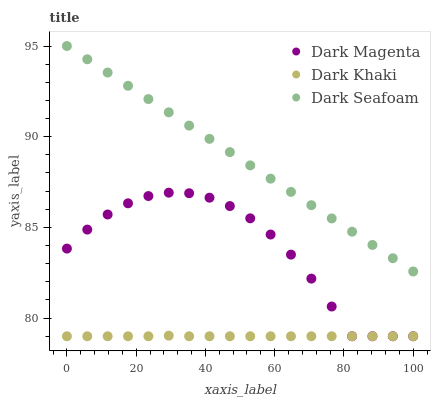Does Dark Khaki have the minimum area under the curve?
Answer yes or no. Yes. Does Dark Seafoam have the maximum area under the curve?
Answer yes or no. Yes. Does Dark Magenta have the minimum area under the curve?
Answer yes or no. No. Does Dark Magenta have the maximum area under the curve?
Answer yes or no. No. Is Dark Seafoam the smoothest?
Answer yes or no. Yes. Is Dark Magenta the roughest?
Answer yes or no. Yes. Is Dark Magenta the smoothest?
Answer yes or no. No. Is Dark Seafoam the roughest?
Answer yes or no. No. Does Dark Khaki have the lowest value?
Answer yes or no. Yes. Does Dark Seafoam have the lowest value?
Answer yes or no. No. Does Dark Seafoam have the highest value?
Answer yes or no. Yes. Does Dark Magenta have the highest value?
Answer yes or no. No. Is Dark Khaki less than Dark Seafoam?
Answer yes or no. Yes. Is Dark Seafoam greater than Dark Magenta?
Answer yes or no. Yes. Does Dark Khaki intersect Dark Magenta?
Answer yes or no. Yes. Is Dark Khaki less than Dark Magenta?
Answer yes or no. No. Is Dark Khaki greater than Dark Magenta?
Answer yes or no. No. Does Dark Khaki intersect Dark Seafoam?
Answer yes or no. No. 